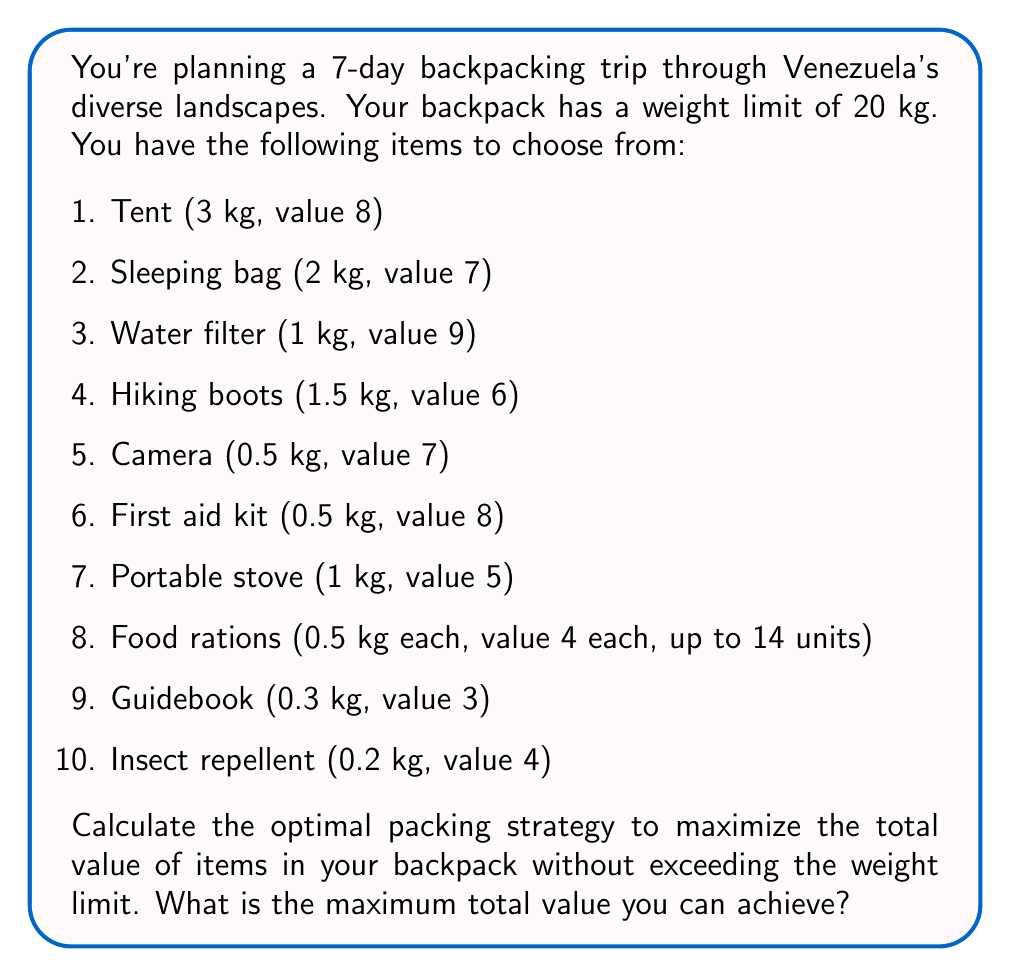What is the answer to this math problem? This problem is a classic example of the 0/1 Knapsack Problem, which can be solved using dynamic programming. Let's approach this step-by-step:

1) First, we'll create a 2D array $dp[i][w]$ where $i$ represents the item number and $w$ represents the weight. $dp[i][w]$ will store the maximum value that can be achieved with the first $i$ items and a weight limit of $w$.

2) We'll initialize the array with 0s.

3) For each item $i$ and each weight $w$ from 0 to 20, we'll fill the array using the following formula:

   $$dp[i][w] = \max(dp[i-1][w], dp[i-1][w-weight[i]] + value[i])$$

   Where $weight[i]$ and $value[i]$ are the weight and value of item $i$ respectively.

4) For the food rations, we'll treat each 0.5 kg unit as a separate item.

5) Here's the pseudo-code for the algorithm:

   ```
   for i from 1 to n:
       for w from 0 to W:
           if weight[i] <= w:
               dp[i][w] = max(dp[i-1][w], dp[i-1][w-weight[i]] + value[i])
           else:
               dp[i][w] = dp[i-1][w]
   ```

6) After filling the array, the value in $dp[n][W]$ (where $n$ is the total number of items and $W$ is the weight limit) will give us the maximum achievable value.

7) To find which items were selected, we can backtrack through the array.

For this specific problem:
- We have 23 items in total (10 unique items + 14 food ration units - 1 because food rations are counted separately)
- The weight limit is 20 kg

After applying the algorithm, we find that the maximum value achievable is 102.

The optimal packing strategy includes:
- Tent (3 kg, value 8)
- Sleeping bag (2 kg, value 7)
- Water filter (1 kg, value 9)
- Camera (0.5 kg, value 7)
- First aid kit (0.5 kg, value 8)
- Portable stove (1 kg, value 5)
- 11 units of food rations (5.5 kg, value 44)
- Guidebook (0.3 kg, value 3)
- Insect repellent (0.2 kg, value 4)

Total weight: 14 kg
Total value: 102
Answer: The maximum total value that can be achieved is 102. 